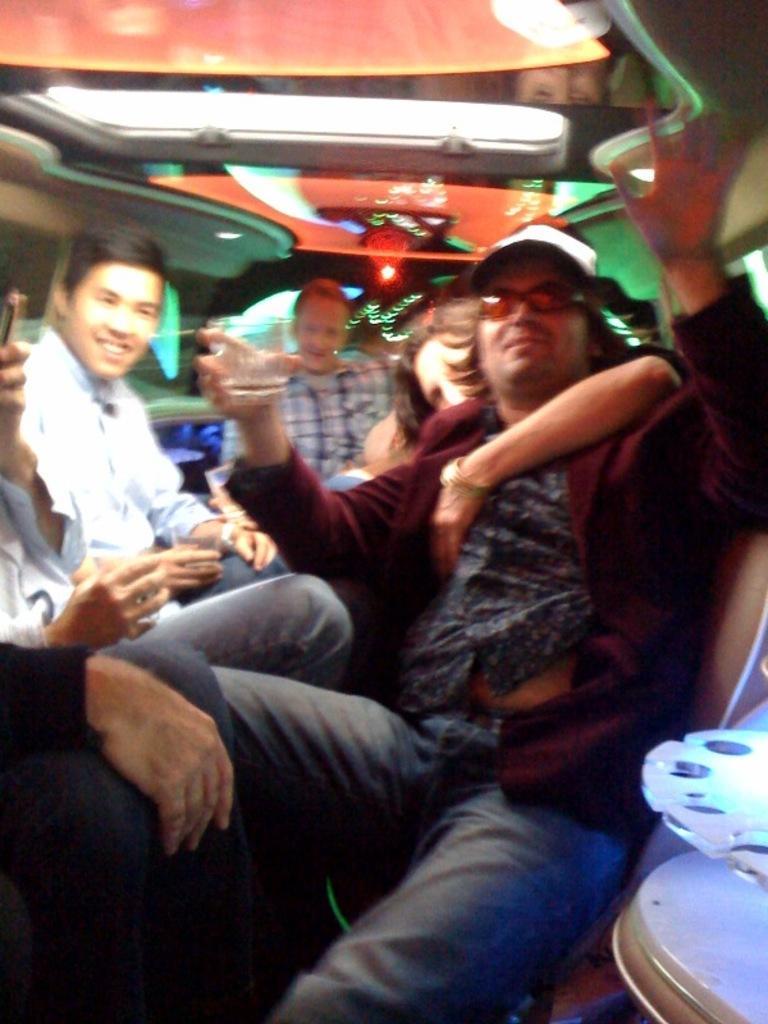Describe this image in one or two sentences. In this picture we can see some people were drinking the wine and sitting on the chair. At the top I can see the lights. 